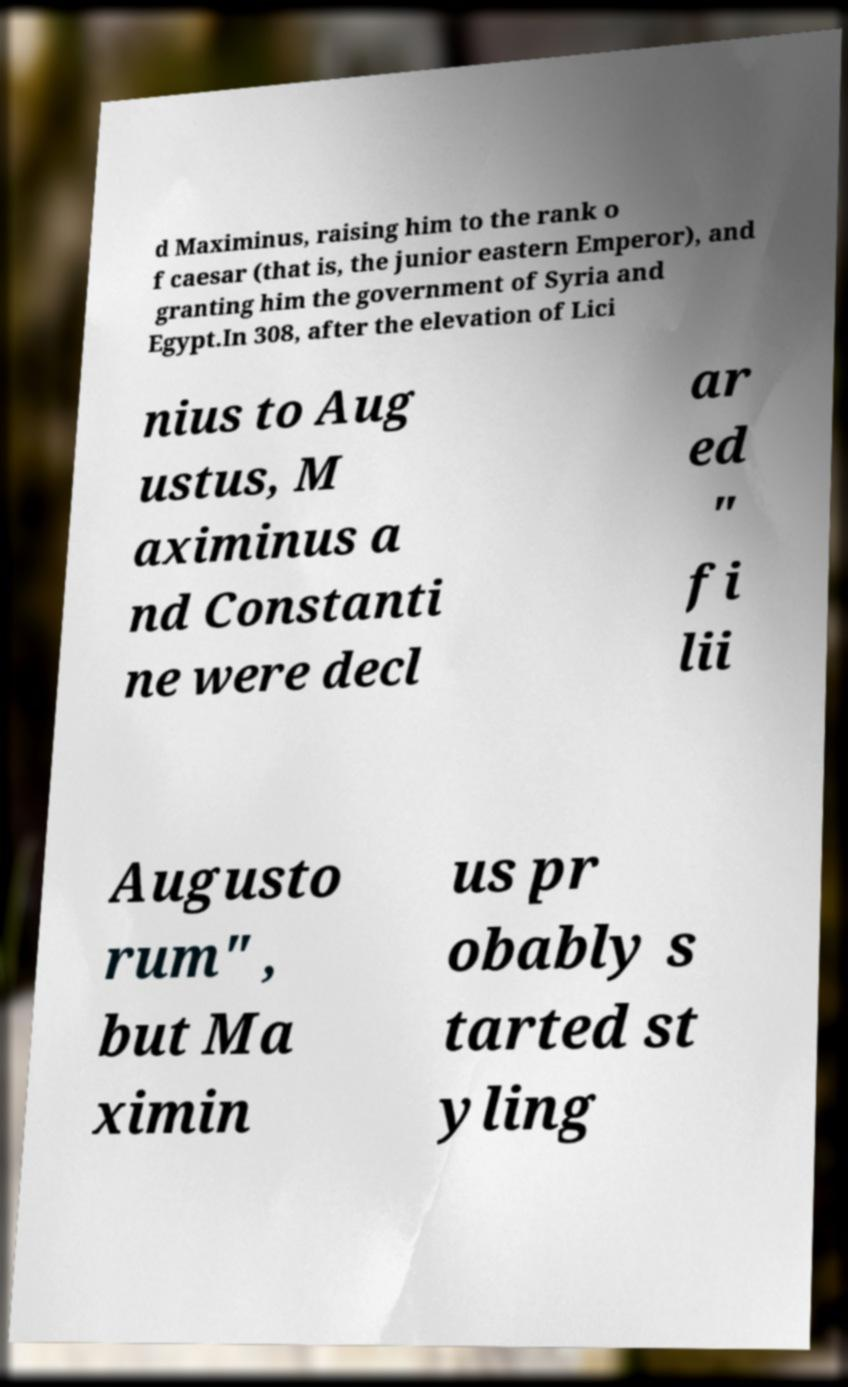Can you accurately transcribe the text from the provided image for me? d Maximinus, raising him to the rank o f caesar (that is, the junior eastern Emperor), and granting him the government of Syria and Egypt.In 308, after the elevation of Lici nius to Aug ustus, M aximinus a nd Constanti ne were decl ar ed " fi lii Augusto rum" , but Ma ximin us pr obably s tarted st yling 